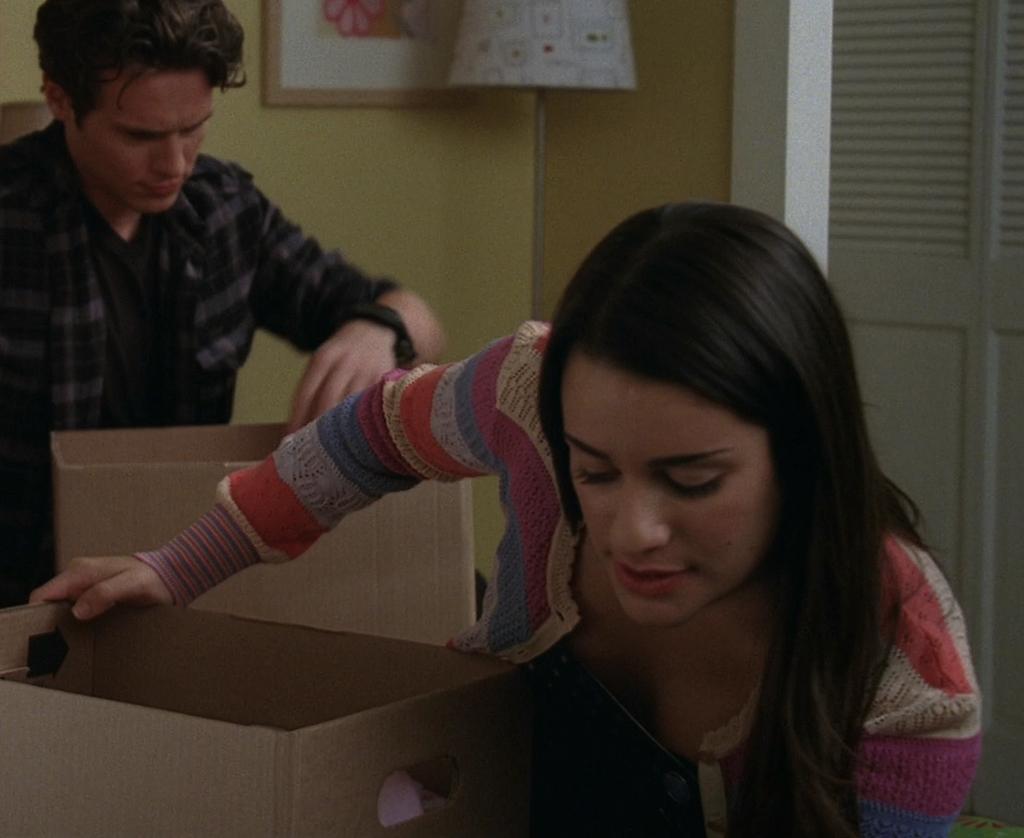In one or two sentences, can you explain what this image depicts? In this image I can see two people with different color dresses. I can see these people are holding the cardboard boxes. In the background I can see the lamp and the frame to the wall. To the right I can see the door. 